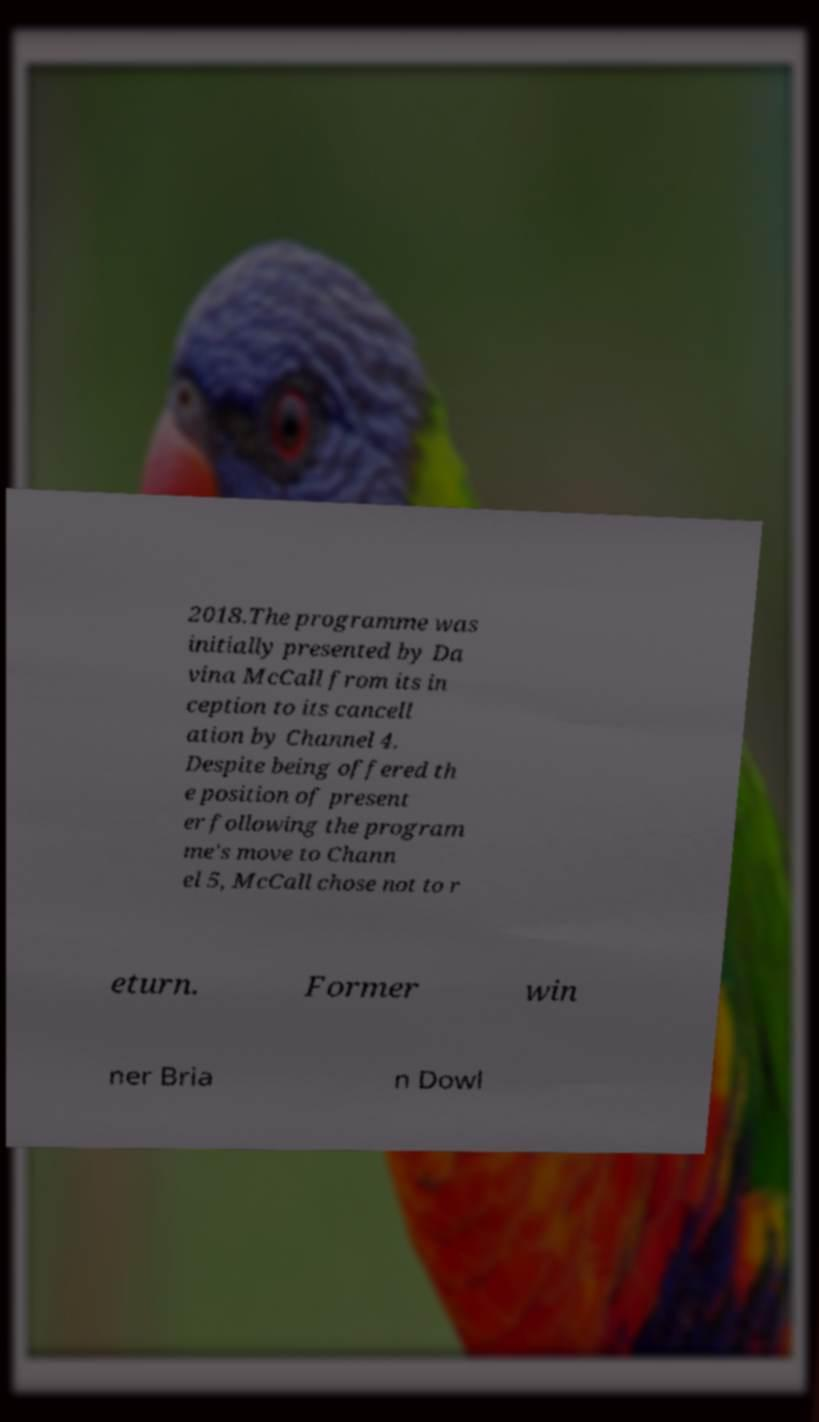What messages or text are displayed in this image? I need them in a readable, typed format. 2018.The programme was initially presented by Da vina McCall from its in ception to its cancell ation by Channel 4. Despite being offered th e position of present er following the program me's move to Chann el 5, McCall chose not to r eturn. Former win ner Bria n Dowl 